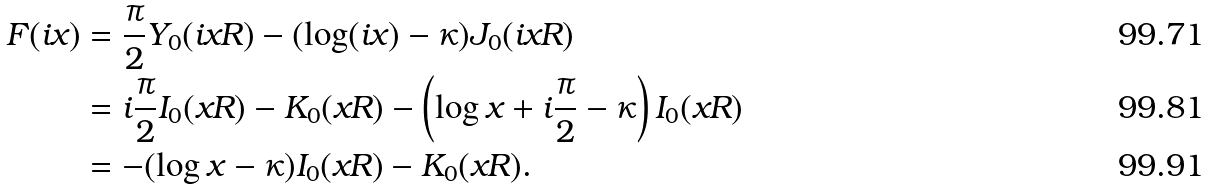<formula> <loc_0><loc_0><loc_500><loc_500>F ( i x ) & = \frac { \pi } { 2 } Y _ { 0 } ( i x R ) - ( \log ( i x ) - \kappa ) J _ { 0 } ( i x R ) \\ & = i \frac { \pi } { 2 } I _ { 0 } ( x R ) - K _ { 0 } ( x R ) - \left ( \log x + i \frac { \pi } { 2 } - \kappa \right ) I _ { 0 } ( x R ) \\ & = - ( \log x - \kappa ) I _ { 0 } ( x R ) - K _ { 0 } ( x R ) .</formula> 